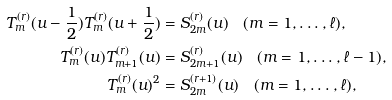<formula> <loc_0><loc_0><loc_500><loc_500>T ^ { ( r ) } _ { m } ( u - \frac { 1 } { 2 } ) T ^ { ( r ) } _ { m } ( u + \frac { 1 } { 2 } ) & = S ^ { ( r ) } _ { 2 m } ( u ) \quad ( m = 1 , \dots , \ell ) , \\ T ^ { ( r ) } _ { m } ( u ) T ^ { ( r ) } _ { m + 1 } ( u ) & = S ^ { ( r ) } _ { 2 m + 1 } ( u ) \quad ( m = 1 , \dots , \ell - 1 ) , \\ T ^ { ( r ) } _ { m } ( u ) ^ { 2 } & = S ^ { ( r + 1 ) } _ { 2 m } ( u ) \quad ( m = 1 , \dots , \ell ) ,</formula> 